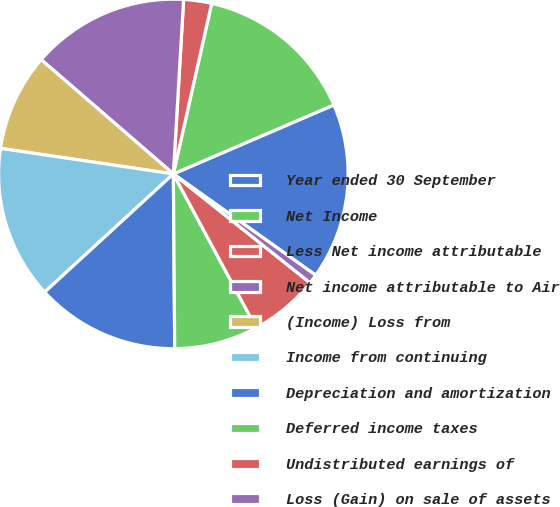Convert chart. <chart><loc_0><loc_0><loc_500><loc_500><pie_chart><fcel>Year ended 30 September<fcel>Net Income<fcel>Less Net income attributable<fcel>Net income attributable to Air<fcel>(Income) Loss from<fcel>Income from continuing<fcel>Depreciation and amortization<fcel>Deferred income taxes<fcel>Undistributed earnings of<fcel>Loss (Gain) on sale of assets<nl><fcel>16.31%<fcel>15.02%<fcel>2.58%<fcel>14.59%<fcel>9.01%<fcel>14.16%<fcel>13.3%<fcel>7.73%<fcel>6.44%<fcel>0.86%<nl></chart> 